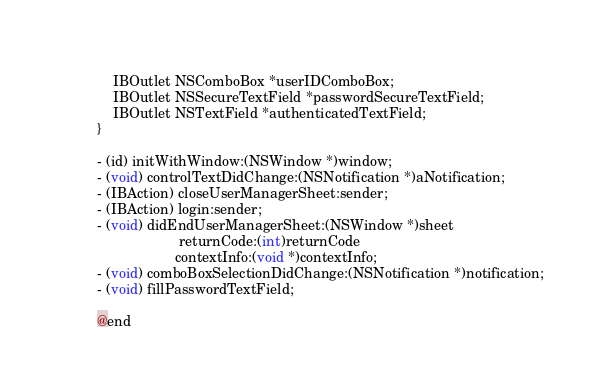<code> <loc_0><loc_0><loc_500><loc_500><_C_>	
	IBOutlet NSComboBox *userIDComboBox;
	IBOutlet NSSecureTextField *passwordSecureTextField;
	IBOutlet NSTextField *authenticatedTextField;
}

- (id) initWithWindow:(NSWindow *)window;
- (void) controlTextDidChange:(NSNotification *)aNotification;
- (IBAction) closeUserManagerSheet:sender;
- (IBAction) login:sender;
- (void) didEndUserManagerSheet:(NSWindow *)sheet
					 returnCode:(int)returnCode
					contextInfo:(void *)contextInfo;
- (void) comboBoxSelectionDidChange:(NSNotification *)notification;
- (void) fillPasswordTextField;

@end
</code> 